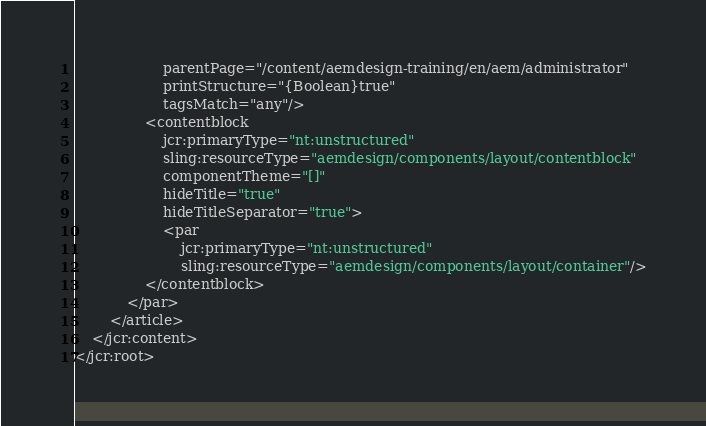<code> <loc_0><loc_0><loc_500><loc_500><_XML_>                    parentPage="/content/aemdesign-training/en/aem/administrator"
                    printStructure="{Boolean}true"
                    tagsMatch="any"/>
                <contentblock
                    jcr:primaryType="nt:unstructured"
                    sling:resourceType="aemdesign/components/layout/contentblock"
                    componentTheme="[]"
                    hideTitle="true"
                    hideTitleSeparator="true">
                    <par
                        jcr:primaryType="nt:unstructured"
                        sling:resourceType="aemdesign/components/layout/container"/>
                </contentblock>
            </par>
        </article>
    </jcr:content>
</jcr:root>
</code> 